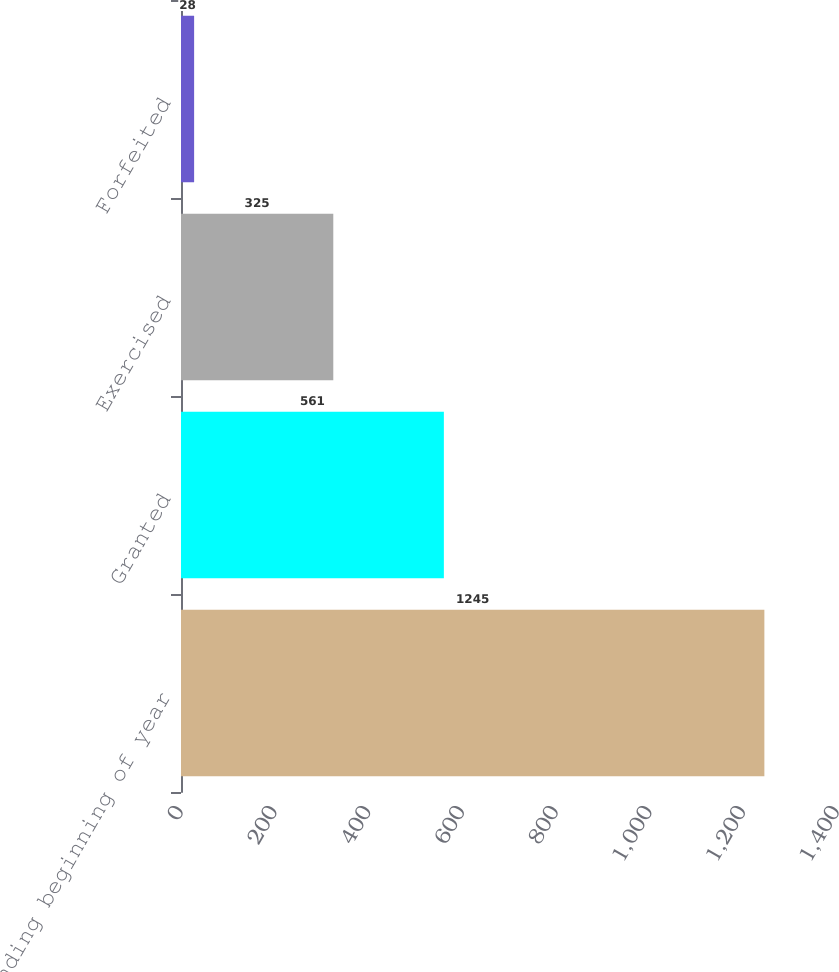Convert chart to OTSL. <chart><loc_0><loc_0><loc_500><loc_500><bar_chart><fcel>Outstanding beginning of year<fcel>Granted<fcel>Exercised<fcel>Forfeited<nl><fcel>1245<fcel>561<fcel>325<fcel>28<nl></chart> 